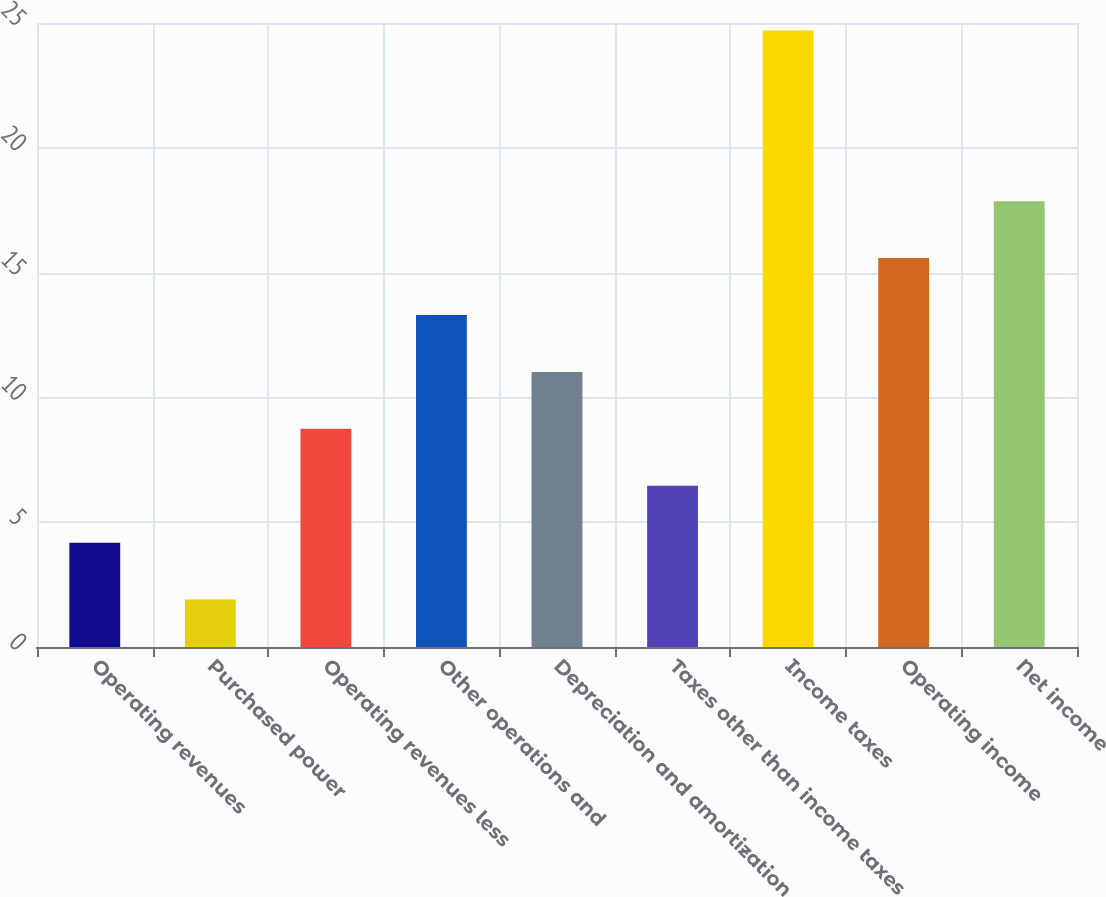<chart> <loc_0><loc_0><loc_500><loc_500><bar_chart><fcel>Operating revenues<fcel>Purchased power<fcel>Operating revenues less<fcel>Other operations and<fcel>Depreciation and amortization<fcel>Taxes other than income taxes<fcel>Income taxes<fcel>Operating income<fcel>Net income<nl><fcel>4.18<fcel>1.9<fcel>8.74<fcel>13.3<fcel>11.02<fcel>6.46<fcel>24.7<fcel>15.58<fcel>17.86<nl></chart> 